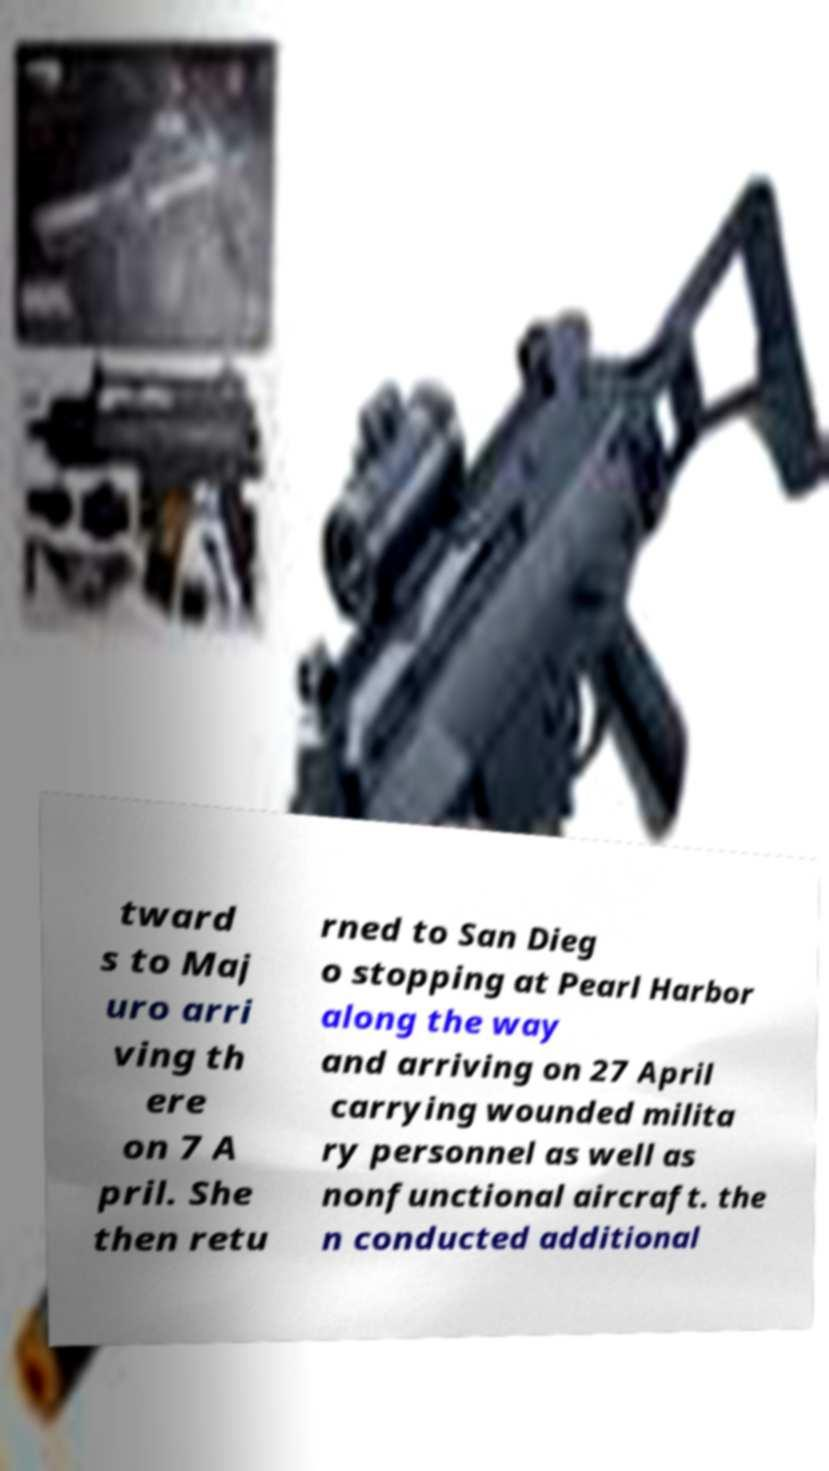For documentation purposes, I need the text within this image transcribed. Could you provide that? tward s to Maj uro arri ving th ere on 7 A pril. She then retu rned to San Dieg o stopping at Pearl Harbor along the way and arriving on 27 April carrying wounded milita ry personnel as well as nonfunctional aircraft. the n conducted additional 